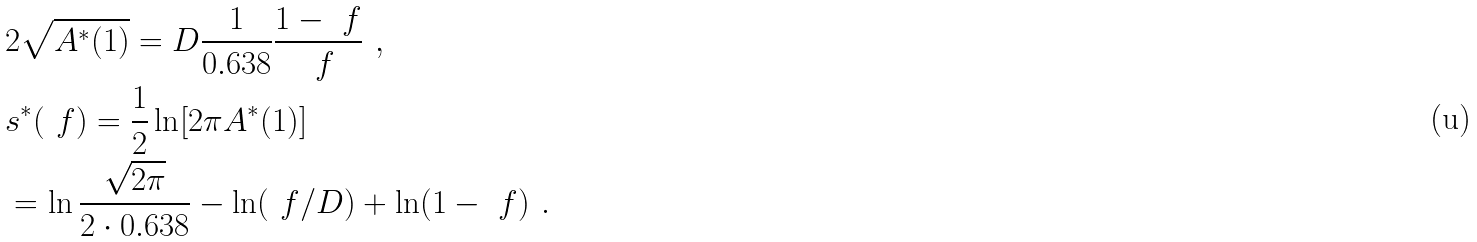Convert formula to latex. <formula><loc_0><loc_0><loc_500><loc_500>& 2 \sqrt { A ^ { * } ( 1 ) } = D \frac { 1 } { 0 . 6 3 8 } \frac { 1 - \ f } { \ f } \ , \\ & s ^ { * } ( \ f ) = \frac { 1 } { 2 } \ln [ 2 \pi A ^ { * } ( 1 ) ] \\ & = \ln \frac { \sqrt { 2 \pi } } { 2 \cdot 0 . 6 3 8 } - \ln ( \ f / D ) + \ln ( 1 - \ f ) \ .</formula> 